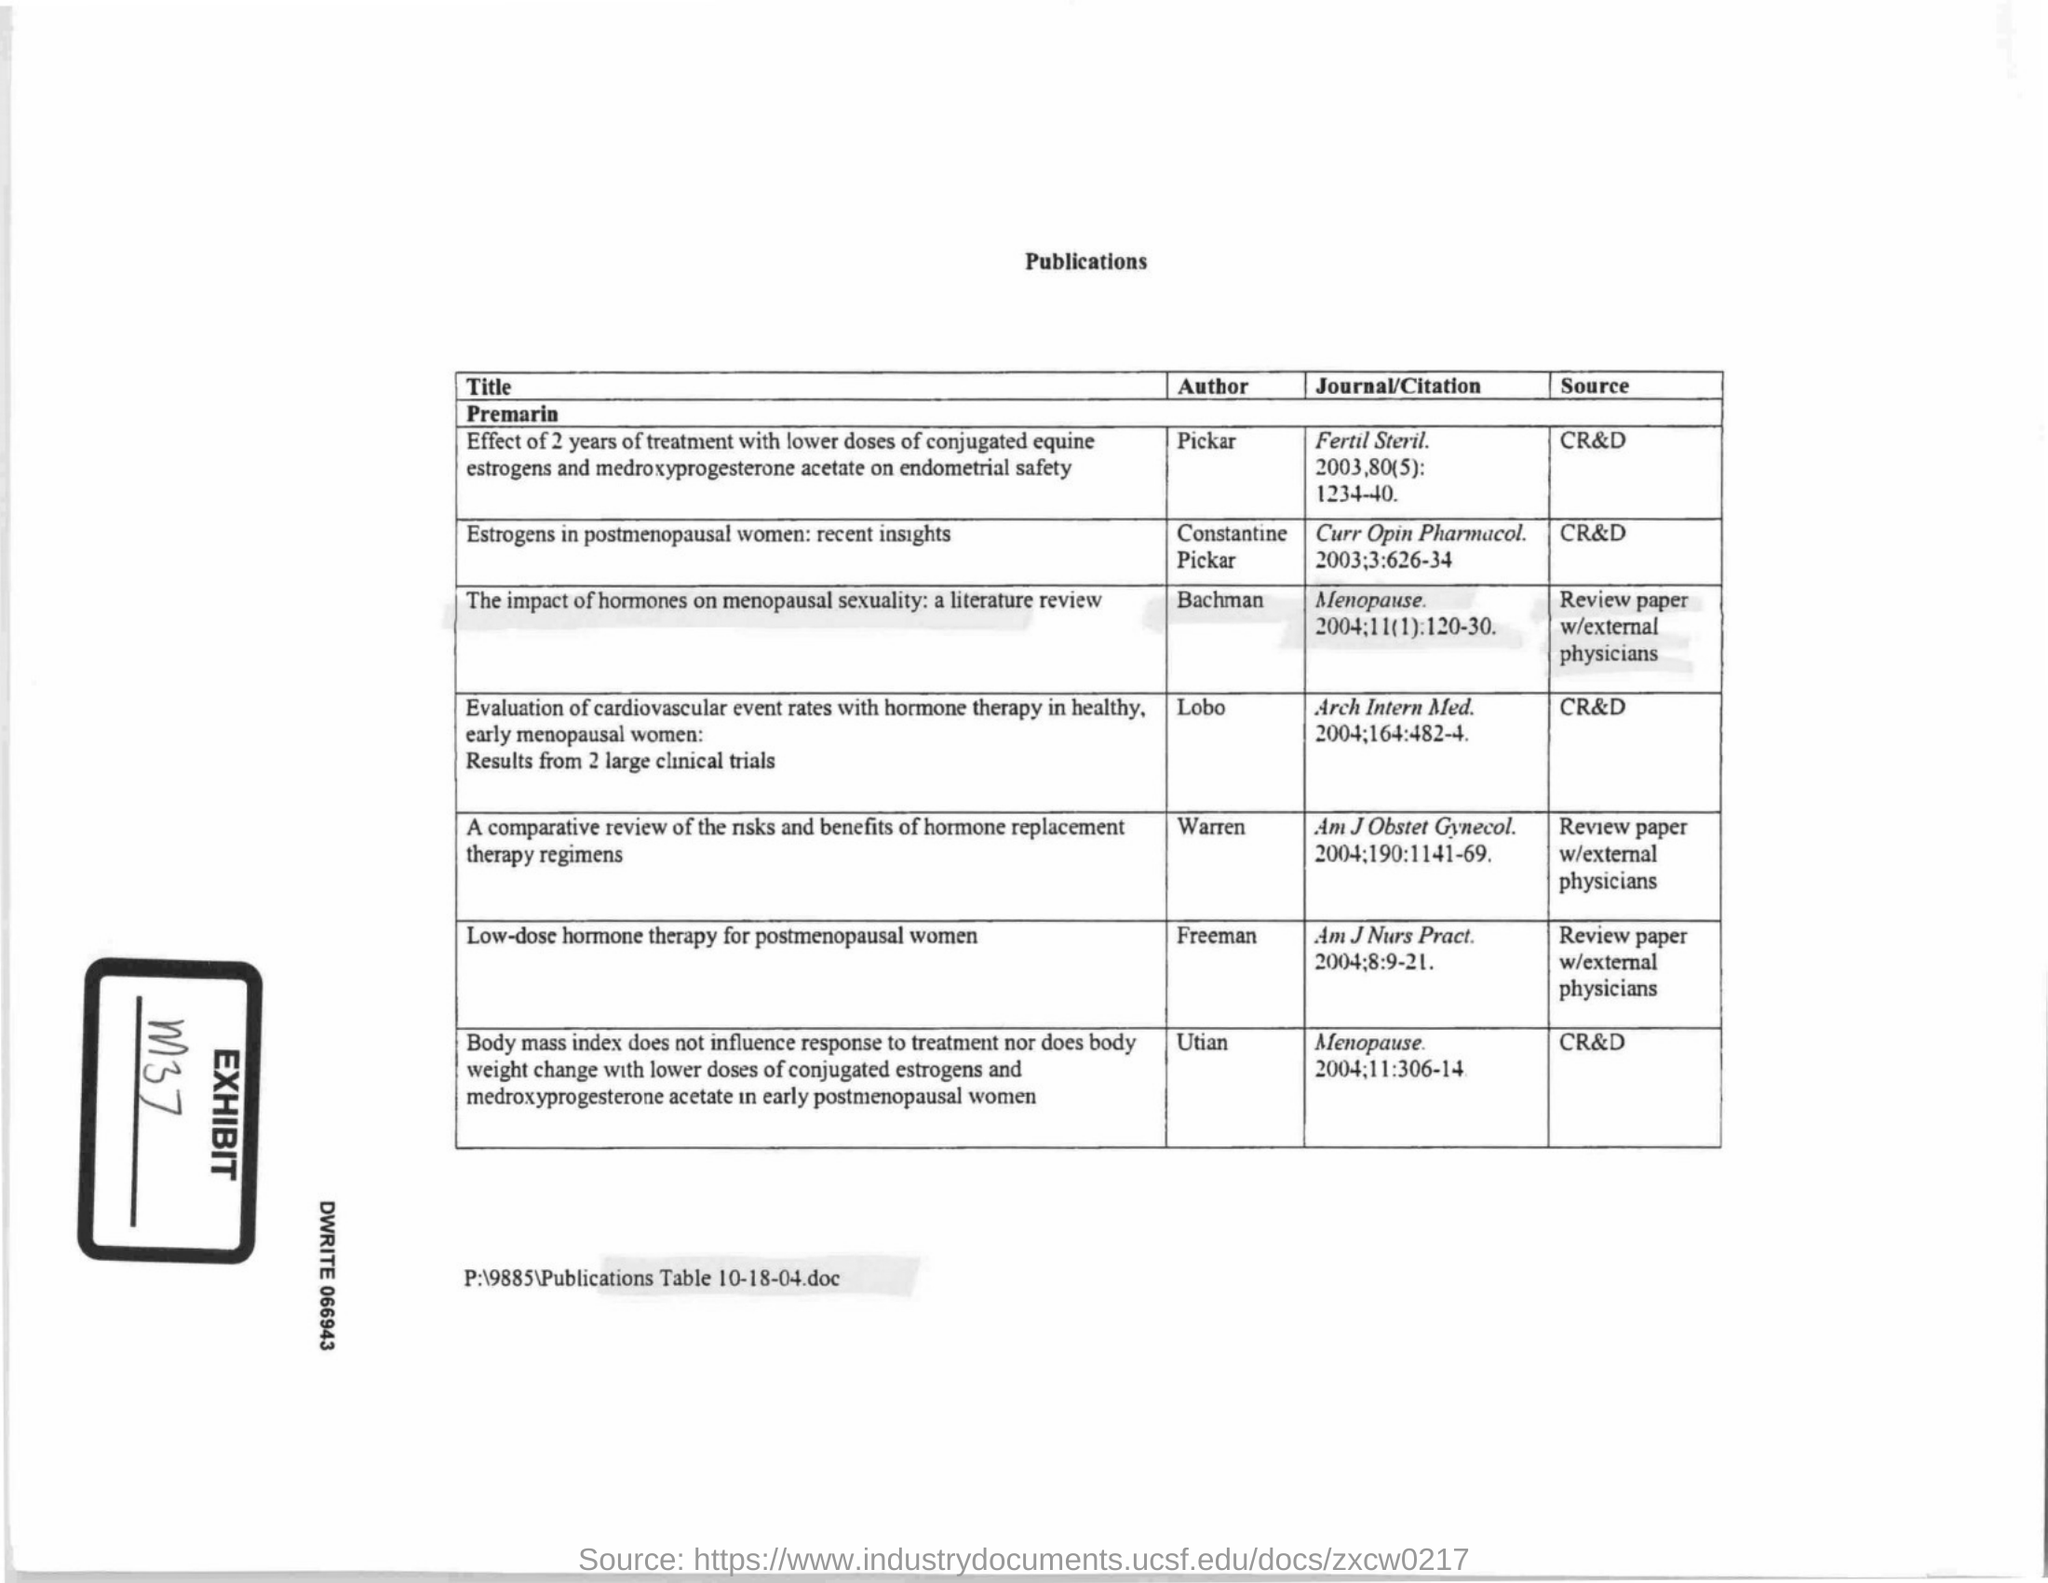Specify some key components in this picture. The author of the paper titled "Low-dose hormone therapy for postmenopausal women" is Freeman. The article titled "Estrogens in postmenopausal women: recent insights" was authored by Constantino Pickar. The Exhibit Number mentioned in the document is m37.. 